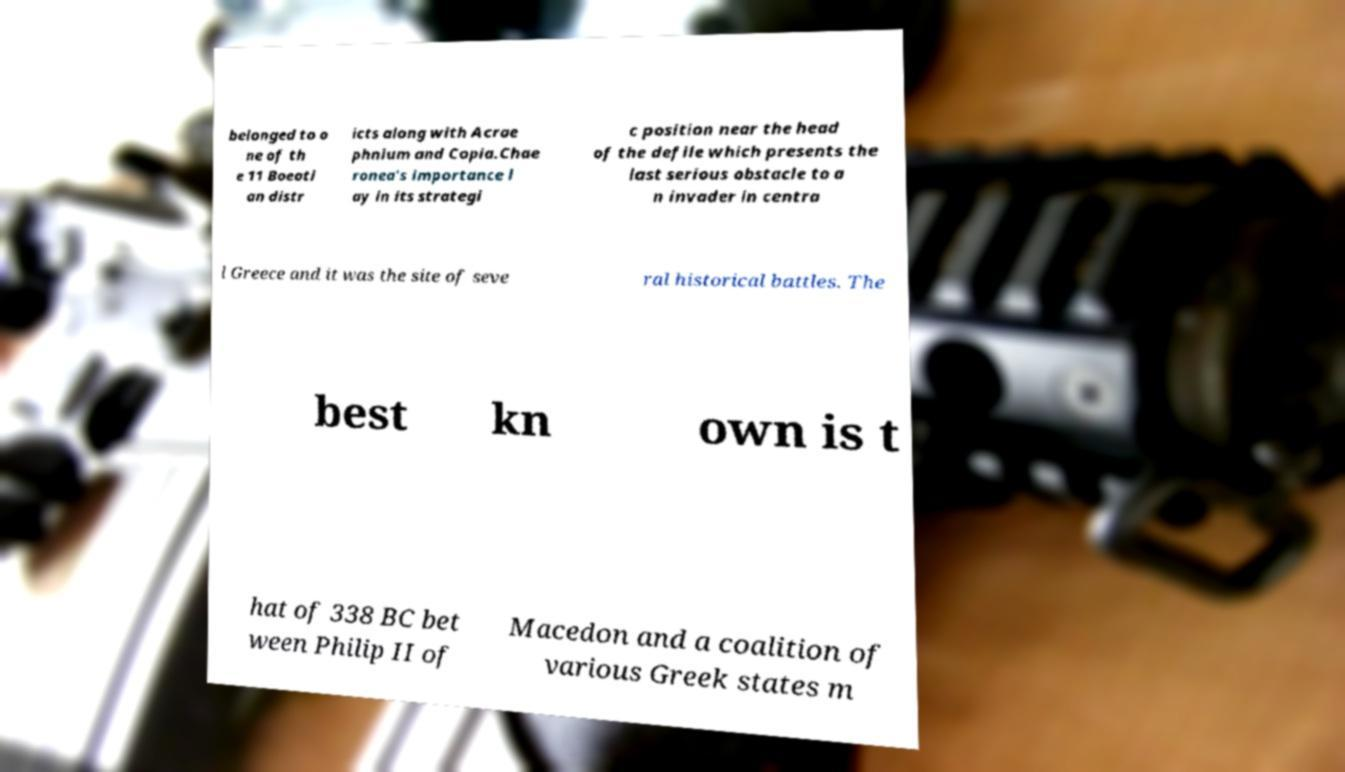There's text embedded in this image that I need extracted. Can you transcribe it verbatim? belonged to o ne of th e 11 Boeoti an distr icts along with Acrae phnium and Copia.Chae ronea's importance l ay in its strategi c position near the head of the defile which presents the last serious obstacle to a n invader in centra l Greece and it was the site of seve ral historical battles. The best kn own is t hat of 338 BC bet ween Philip II of Macedon and a coalition of various Greek states m 